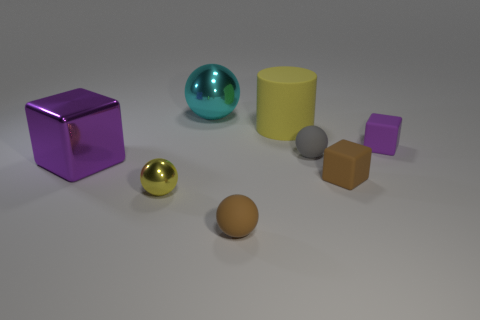Add 2 purple matte blocks. How many objects exist? 10 Subtract all tiny brown blocks. How many blocks are left? 2 Subtract all blue balls. Subtract all brown cylinders. How many balls are left? 4 Subtract all purple cylinders. How many gray blocks are left? 0 Subtract all rubber cylinders. Subtract all purple rubber things. How many objects are left? 6 Add 8 yellow matte things. How many yellow matte things are left? 9 Add 3 large shiny things. How many large shiny things exist? 5 Subtract all brown blocks. How many blocks are left? 2 Subtract 0 blue cubes. How many objects are left? 8 Subtract all blocks. How many objects are left? 5 